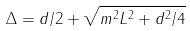<formula> <loc_0><loc_0><loc_500><loc_500>\Delta = d / 2 + \sqrt { m ^ { 2 } L ^ { 2 } + d ^ { 2 } / 4 }</formula> 